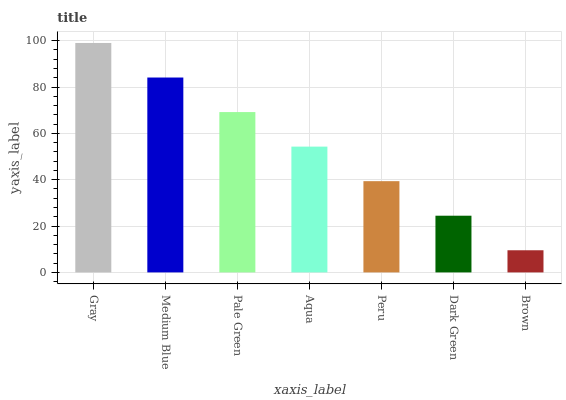Is Brown the minimum?
Answer yes or no. Yes. Is Gray the maximum?
Answer yes or no. Yes. Is Medium Blue the minimum?
Answer yes or no. No. Is Medium Blue the maximum?
Answer yes or no. No. Is Gray greater than Medium Blue?
Answer yes or no. Yes. Is Medium Blue less than Gray?
Answer yes or no. Yes. Is Medium Blue greater than Gray?
Answer yes or no. No. Is Gray less than Medium Blue?
Answer yes or no. No. Is Aqua the high median?
Answer yes or no. Yes. Is Aqua the low median?
Answer yes or no. Yes. Is Pale Green the high median?
Answer yes or no. No. Is Pale Green the low median?
Answer yes or no. No. 